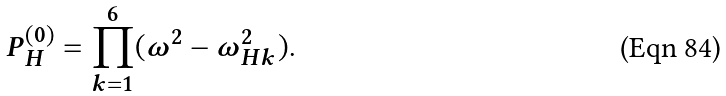<formula> <loc_0><loc_0><loc_500><loc_500>P _ { H } ^ { ( 0 ) } = \prod _ { k = 1 } ^ { 6 } ( \omega ^ { 2 } - \omega _ { H k } ^ { 2 } ) .</formula> 